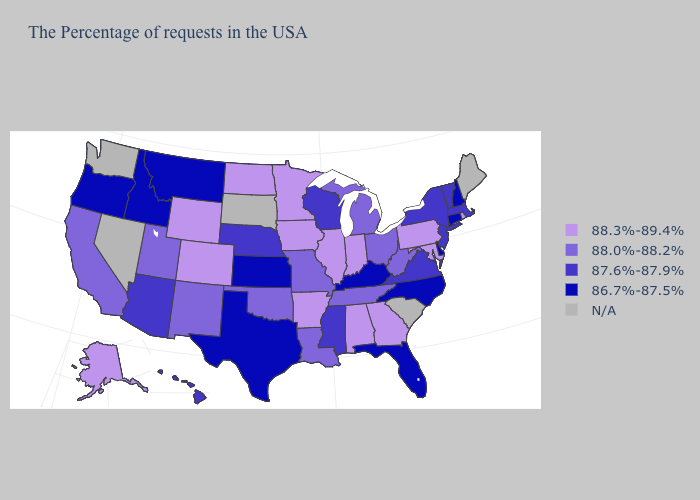Among the states that border Delaware , which have the highest value?
Quick response, please. Maryland, Pennsylvania. Which states have the lowest value in the Northeast?
Answer briefly. New Hampshire, Connecticut. Among the states that border Virginia , which have the highest value?
Keep it brief. Maryland. Does West Virginia have the lowest value in the South?
Write a very short answer. No. What is the highest value in the USA?
Answer briefly. 88.3%-89.4%. Among the states that border Nebraska , does Iowa have the highest value?
Short answer required. Yes. What is the value of Nevada?
Keep it brief. N/A. Which states have the highest value in the USA?
Concise answer only. Rhode Island, Maryland, Pennsylvania, Georgia, Indiana, Alabama, Illinois, Arkansas, Minnesota, Iowa, North Dakota, Wyoming, Colorado, Alaska. What is the value of Minnesota?
Concise answer only. 88.3%-89.4%. Does the first symbol in the legend represent the smallest category?
Keep it brief. No. What is the value of Washington?
Concise answer only. N/A. What is the value of Colorado?
Quick response, please. 88.3%-89.4%. Name the states that have a value in the range 88.0%-88.2%?
Answer briefly. West Virginia, Ohio, Michigan, Tennessee, Louisiana, Missouri, Oklahoma, New Mexico, Utah, California. What is the lowest value in the USA?
Give a very brief answer. 86.7%-87.5%. Which states hav the highest value in the MidWest?
Short answer required. Indiana, Illinois, Minnesota, Iowa, North Dakota. 